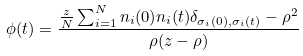Convert formula to latex. <formula><loc_0><loc_0><loc_500><loc_500>\phi ( t ) = \frac { \frac { z } { N } \sum _ { i = 1 } ^ { N } n _ { i } ( 0 ) n _ { i } ( t ) \delta _ { \sigma _ { i } ( 0 ) , \sigma _ { i } ( t ) } - \rho ^ { 2 } } { \rho ( z - \rho ) }</formula> 